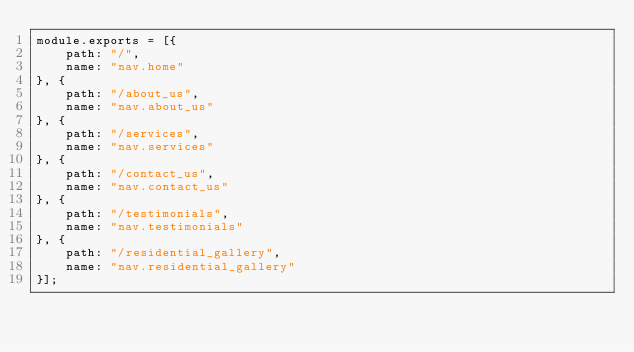<code> <loc_0><loc_0><loc_500><loc_500><_JavaScript_>module.exports = [{
    path: "/",
    name: "nav.home"
}, {
    path: "/about_us",
    name: "nav.about_us"
}, {
    path: "/services",
    name: "nav.services"
}, {
    path: "/contact_us",
    name: "nav.contact_us"
}, {
    path: "/testimonials",
    name: "nav.testimonials"
}, {
    path: "/residential_gallery",
    name: "nav.residential_gallery"
}];
</code> 